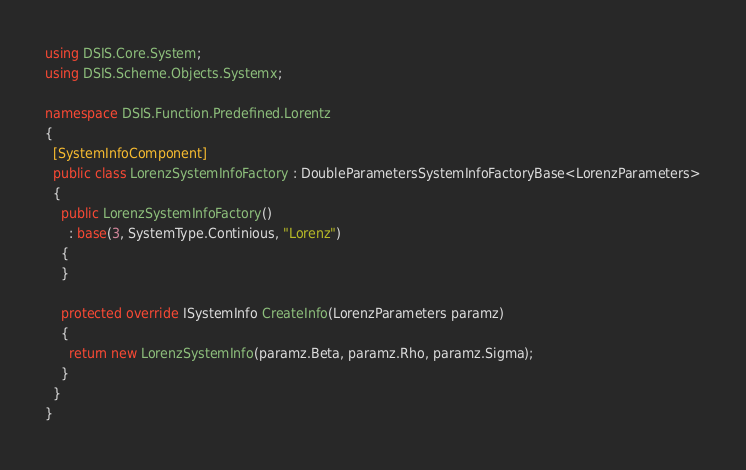Convert code to text. <code><loc_0><loc_0><loc_500><loc_500><_C#_>using DSIS.Core.System;
using DSIS.Scheme.Objects.Systemx;

namespace DSIS.Function.Predefined.Lorentz
{
  [SystemInfoComponent]
  public class LorenzSystemInfoFactory : DoubleParametersSystemInfoFactoryBase<LorenzParameters>
  {
    public LorenzSystemInfoFactory()
      : base(3, SystemType.Continious, "Lorenz")
    {
    }

    protected override ISystemInfo CreateInfo(LorenzParameters paramz)
    {
      return new LorenzSystemInfo(paramz.Beta, paramz.Rho, paramz.Sigma);
    }
  }
}</code> 